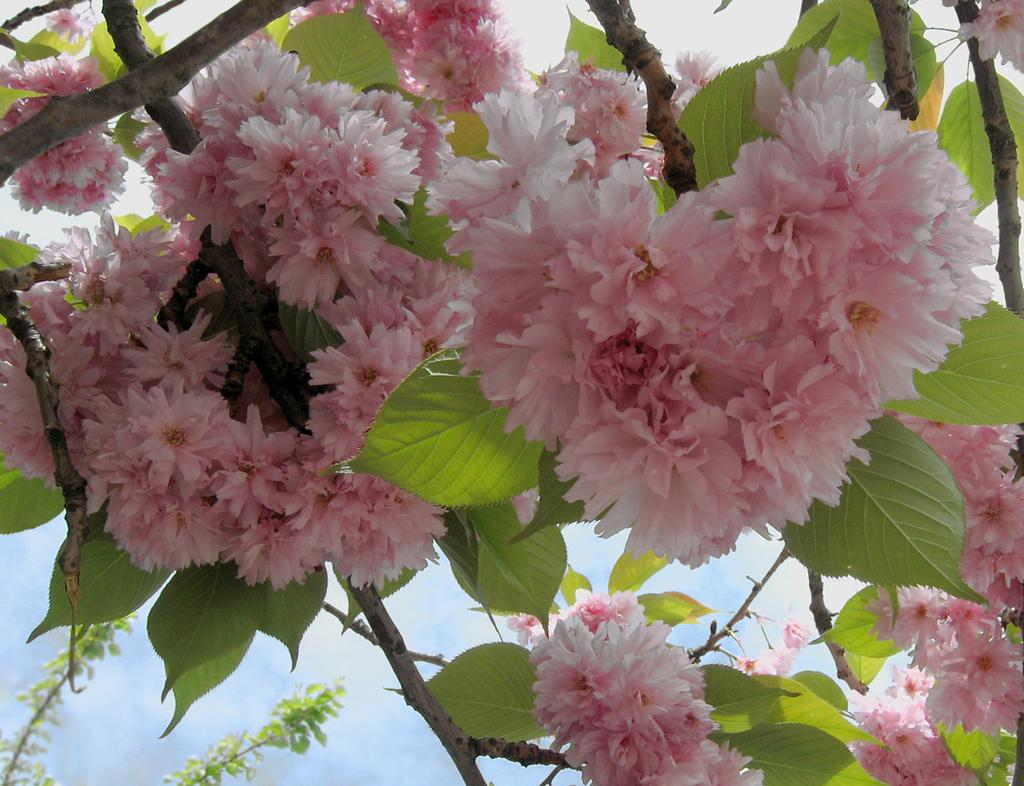What type of architectural feature can be seen in the image? There are steps in the image. What is covering the steps in the image? Leaves and flowers are present on the steps. What can be seen in the background of the image? The sky is visible in the background of the image. What type of circle can be seen on the crow's head in the image? There is no crow present in the image, and therefore no circle on its head. 